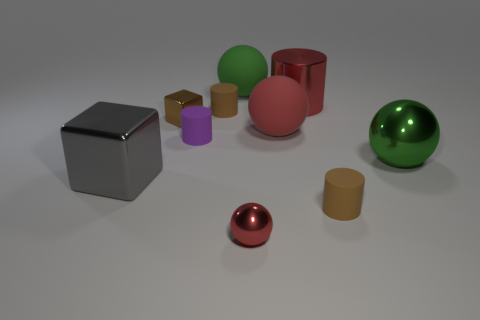There is another tiny red thing that is the same shape as the red matte thing; what is its material?
Offer a very short reply. Metal. How many metal objects are either cylinders or red blocks?
Your answer should be compact. 1. Do the small cylinder that is in front of the small purple object and the ball in front of the green metal thing have the same material?
Offer a very short reply. No. Are there any tiny gray balls?
Your answer should be very brief. No. Do the tiny metal object that is to the left of the green rubber ball and the brown matte object that is to the left of the small red shiny thing have the same shape?
Keep it short and to the point. No. Are there any small blue objects that have the same material as the small purple thing?
Keep it short and to the point. No. Does the brown cylinder that is behind the small metal block have the same material as the tiny block?
Your response must be concise. No. Are there more brown metallic things in front of the large metal sphere than gray things that are on the left side of the big cube?
Keep it short and to the point. No. There is a block that is the same size as the green rubber ball; what is its color?
Your answer should be very brief. Gray. Are there any metal cylinders that have the same color as the large cube?
Your answer should be very brief. No. 